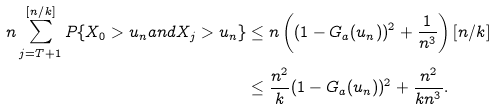Convert formula to latex. <formula><loc_0><loc_0><loc_500><loc_500>n \sum _ { j = T + 1 } ^ { [ n / k ] } P \{ X _ { 0 } > u _ { n } a n d X _ { j } > u _ { n } \} & \leq n \left ( ( 1 - G _ { a } ( u _ { n } ) ) ^ { 2 } + \frac { 1 } { n ^ { 3 } } \right ) [ n / k ] \\ & \leq \frac { n ^ { 2 } } k ( 1 - G _ { a } ( u _ { n } ) ) ^ { 2 } + \frac { n ^ { 2 } } { k n ^ { 3 } } .</formula> 